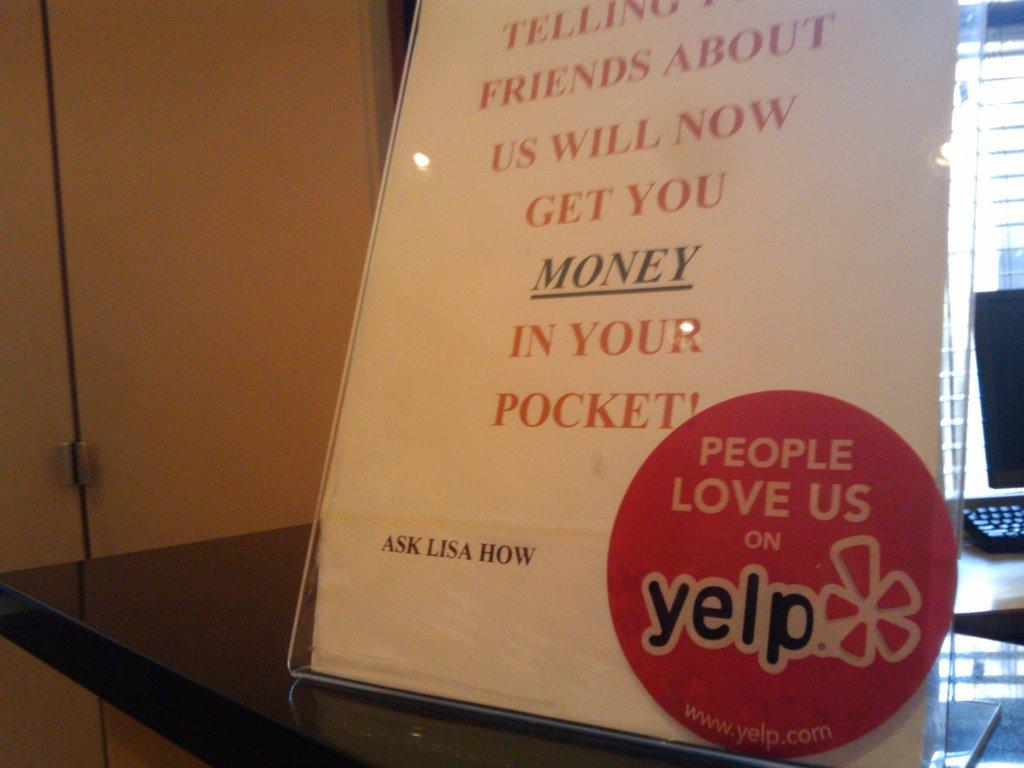Provide a one-sentence caption for the provided image. A sign asking customers to ask lisa how to get money. 